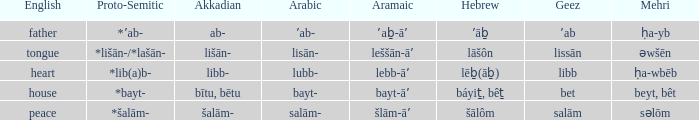If in English it's house, what is it in proto-semitic? *bayt-. 